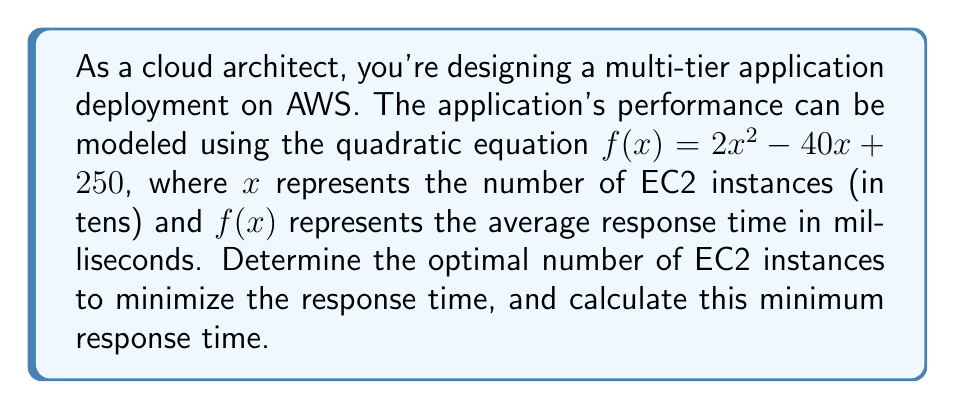Give your solution to this math problem. To solve this problem, we need to follow these steps:

1. Identify the quadratic equation: $f(x) = 2x^2 - 40x + 250$

2. Find the vertex of the parabola, which represents the minimum point. For a quadratic equation in the form $f(x) = ax^2 + bx + c$, the x-coordinate of the vertex is given by $x = -\frac{b}{2a}$.

   In this case, $a = 2$, $b = -40$, and $c = 250$

   $x = -\frac{(-40)}{2(2)} = \frac{40}{4} = 10$

3. The x-coordinate (10) represents the optimal number of EC2 instances in tens. So, the optimal number of instances is 100.

4. To find the minimum response time, substitute $x = 10$ into the original equation:

   $f(10) = 2(10)^2 - 40(10) + 250$
   $= 200 - 400 + 250$
   $= 50$

Therefore, the minimum response time is 50 milliseconds.
Answer: The optimal number of EC2 instances is 100, and the minimum response time is 50 milliseconds. 